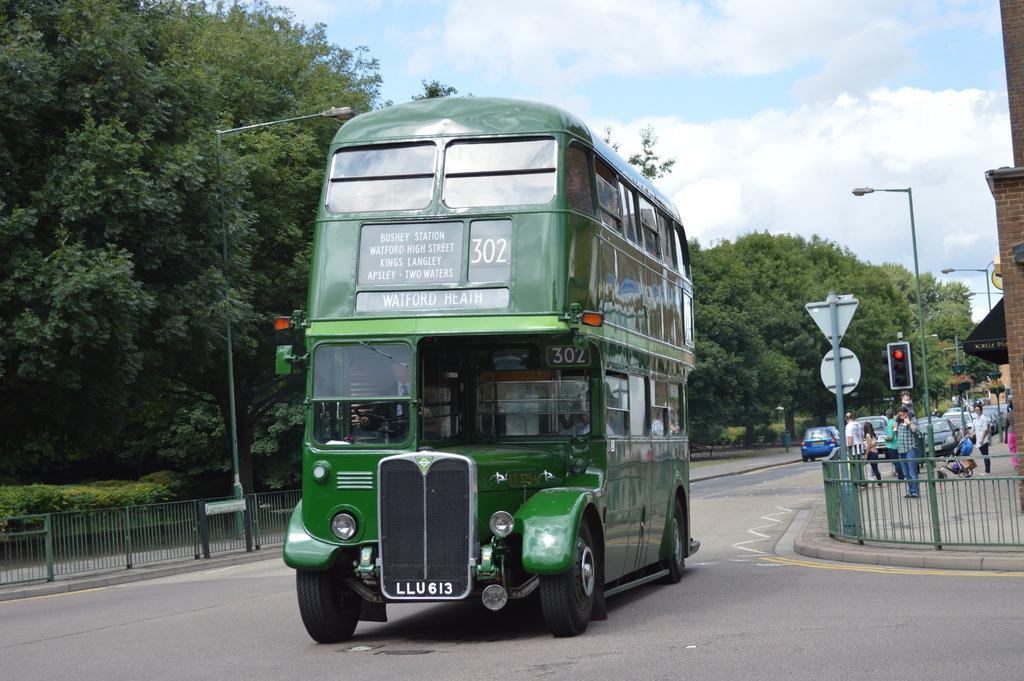Describe this image in one or two sentences. In the picture I can see a double Decker bus on the road. I can see a few people on the side of the road. I can see the metal fence on both sides of the road. There are light poles on both sides of the road. I can see the trees on the side of the road. There is a traffic signal pole on the right side. There are clouds in the sky. 